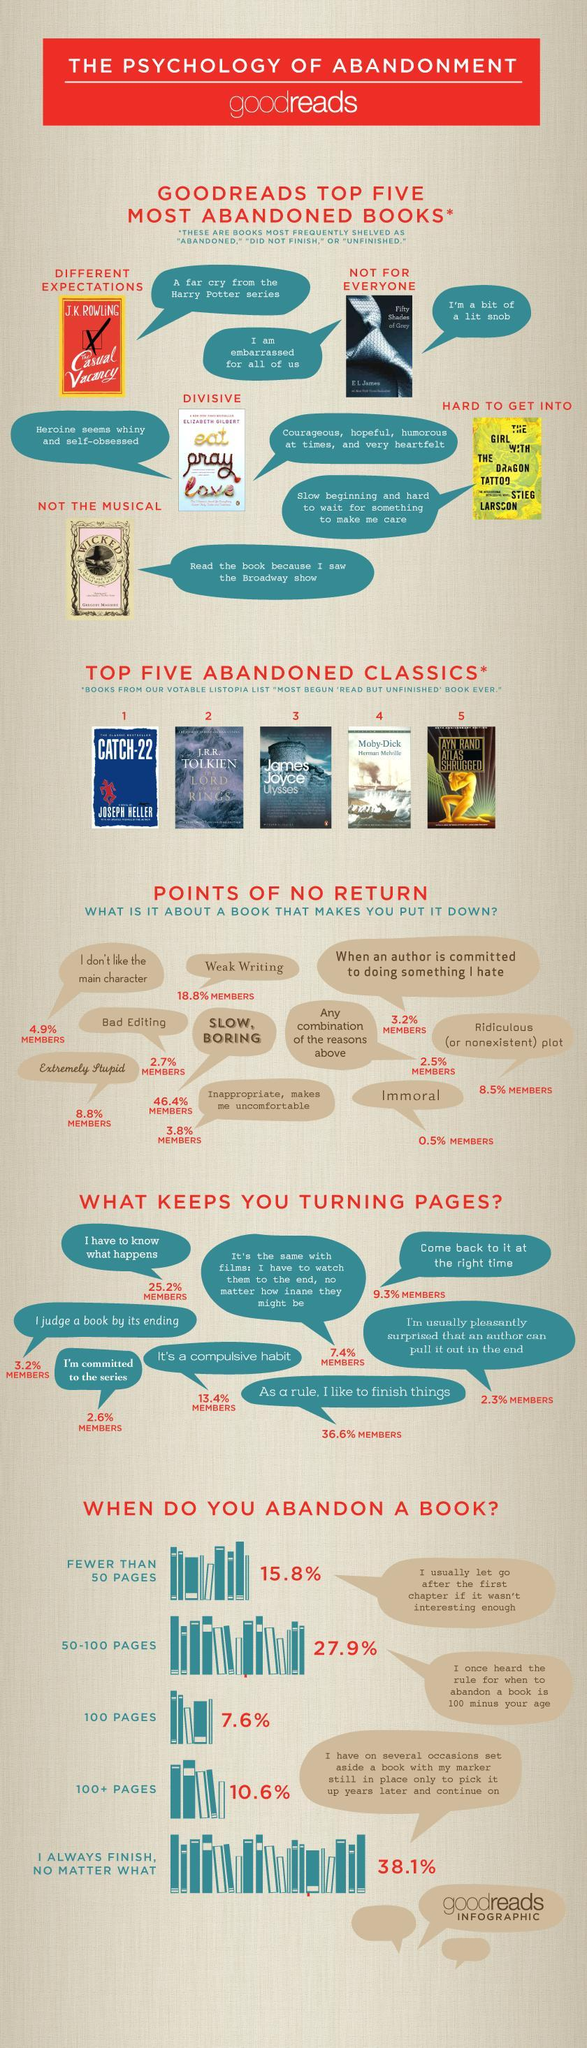What percent of people complete a book always?
Answer the question with a short phrase. 38.1% Who is the author of The Lord of the Rings? J. R. R. TOLKIEN What is the reason the book eat pray love was abandoned by many? Heroine seems whiny and self-obsessed What is the reason that 8.5% members say as a reason to put down a book? Ridiculous (or nonexistent) plot What makes 13.4% of members to keep turning pages? It's a compulsive habit What percent of members put down a book because of bad editing and weak writing? 21.5% What percent of members keep reading a book because they are committed to the series? 2.6% What is the biggest reason to not continue a book? SLOW, BORING What percent of people do not continue a book because it is slow and boring? 46.4% MEMBERS 